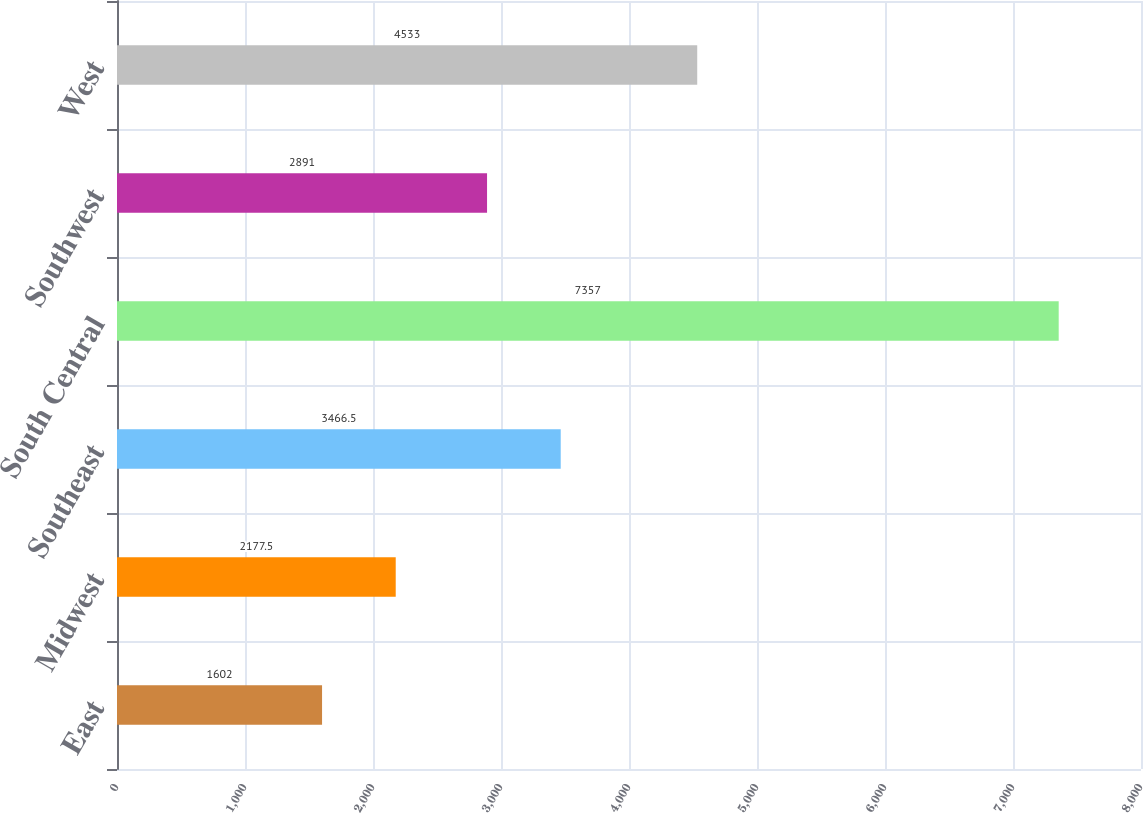Convert chart to OTSL. <chart><loc_0><loc_0><loc_500><loc_500><bar_chart><fcel>East<fcel>Midwest<fcel>Southeast<fcel>South Central<fcel>Southwest<fcel>West<nl><fcel>1602<fcel>2177.5<fcel>3466.5<fcel>7357<fcel>2891<fcel>4533<nl></chart> 